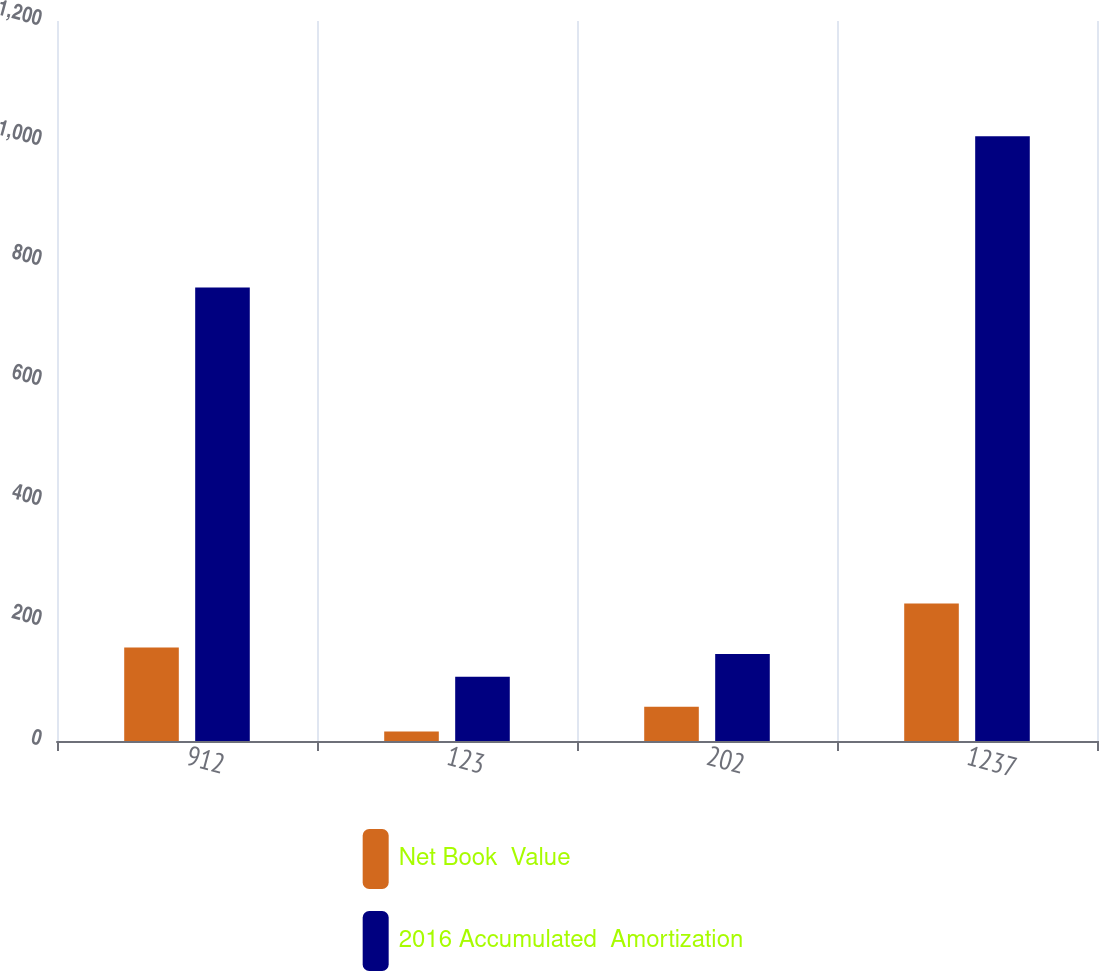Convert chart. <chart><loc_0><loc_0><loc_500><loc_500><stacked_bar_chart><ecel><fcel>912<fcel>123<fcel>202<fcel>1237<nl><fcel>Net Book  Value<fcel>156<fcel>16<fcel>57<fcel>229<nl><fcel>2016 Accumulated  Amortization<fcel>756<fcel>107<fcel>145<fcel>1008<nl></chart> 